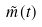<formula> <loc_0><loc_0><loc_500><loc_500>\tilde { m } ( t )</formula> 